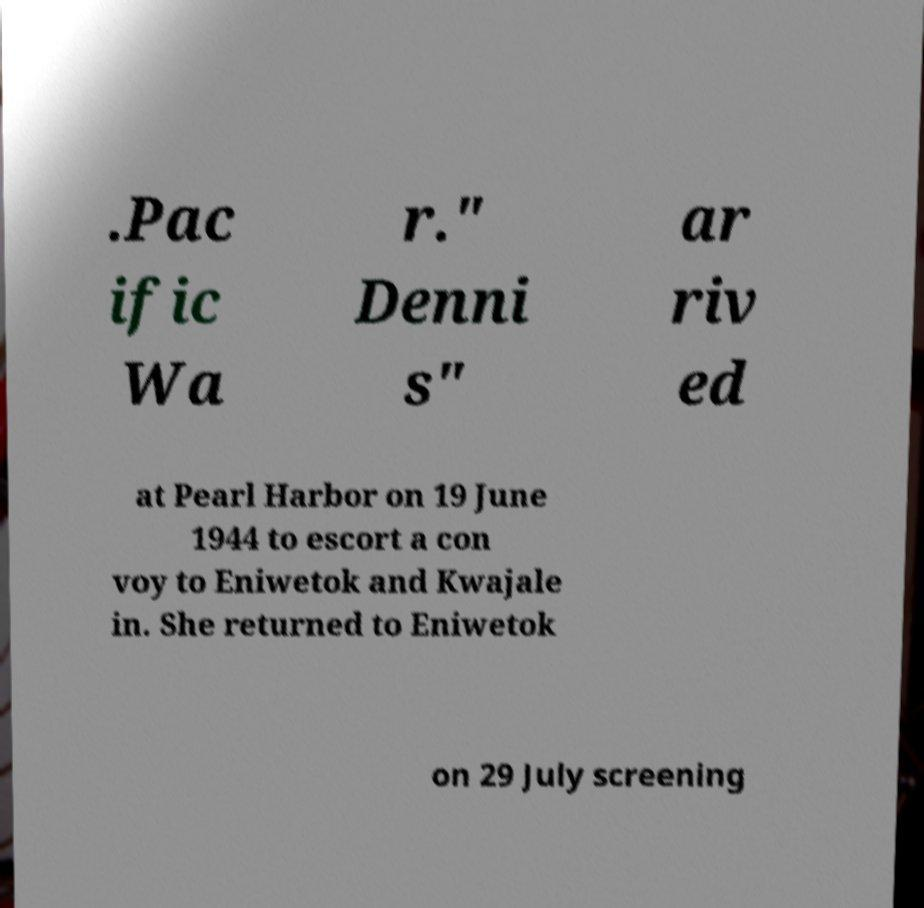There's text embedded in this image that I need extracted. Can you transcribe it verbatim? .Pac ific Wa r." Denni s" ar riv ed at Pearl Harbor on 19 June 1944 to escort a con voy to Eniwetok and Kwajale in. She returned to Eniwetok on 29 July screening 